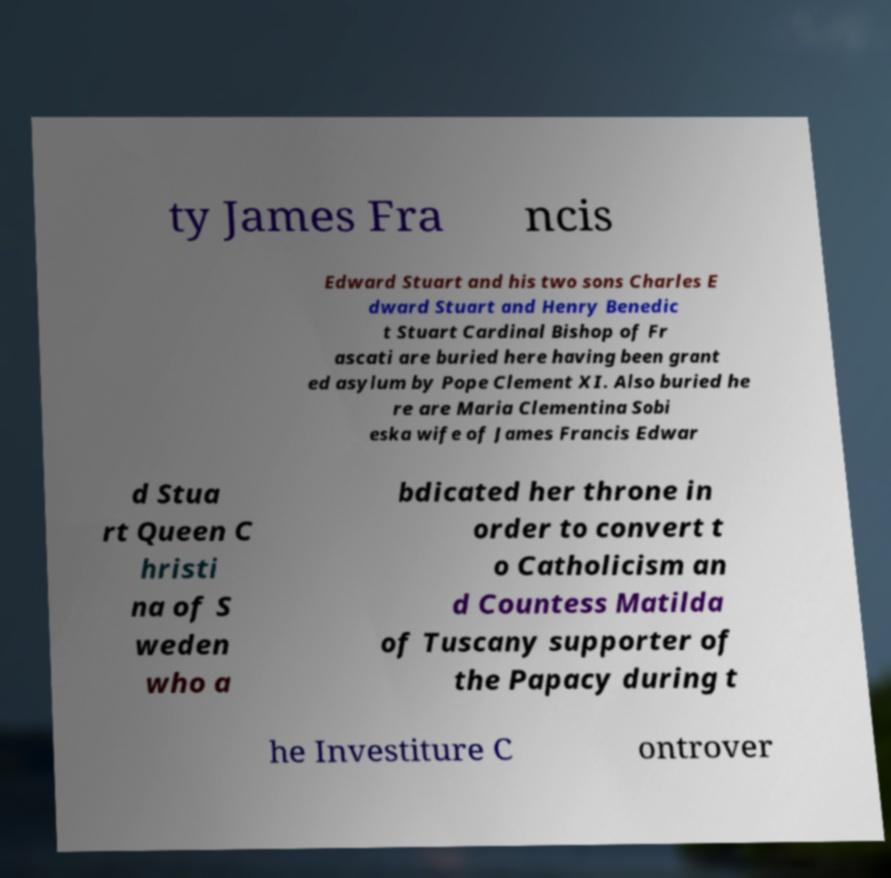What messages or text are displayed in this image? I need them in a readable, typed format. ty James Fra ncis Edward Stuart and his two sons Charles E dward Stuart and Henry Benedic t Stuart Cardinal Bishop of Fr ascati are buried here having been grant ed asylum by Pope Clement XI. Also buried he re are Maria Clementina Sobi eska wife of James Francis Edwar d Stua rt Queen C hristi na of S weden who a bdicated her throne in order to convert t o Catholicism an d Countess Matilda of Tuscany supporter of the Papacy during t he Investiture C ontrover 